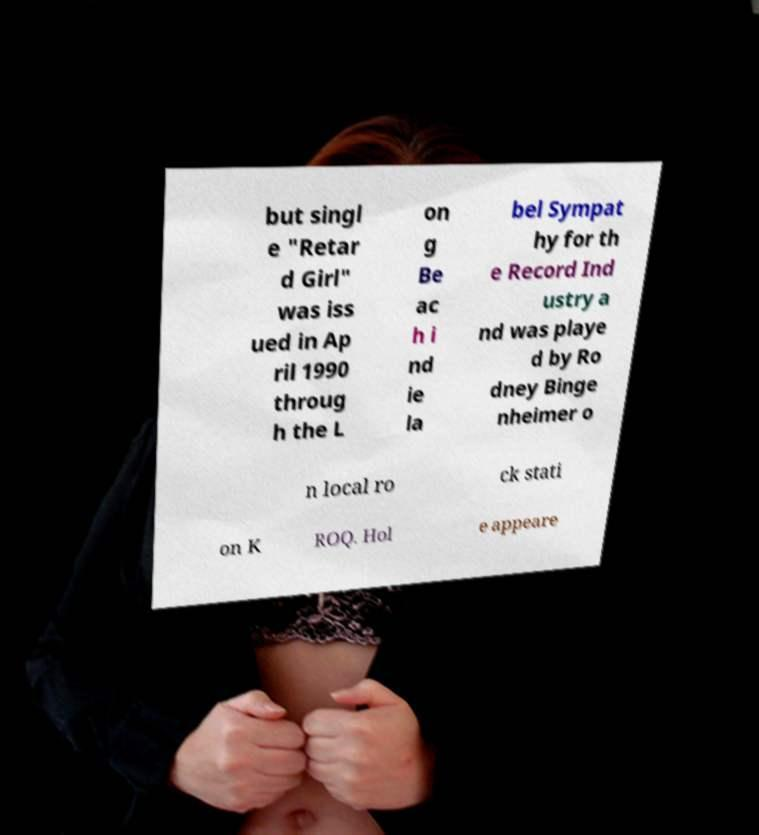Can you read and provide the text displayed in the image?This photo seems to have some interesting text. Can you extract and type it out for me? but singl e "Retar d Girl" was iss ued in Ap ril 1990 throug h the L on g Be ac h i nd ie la bel Sympat hy for th e Record Ind ustry a nd was playe d by Ro dney Binge nheimer o n local ro ck stati on K ROQ. Hol e appeare 